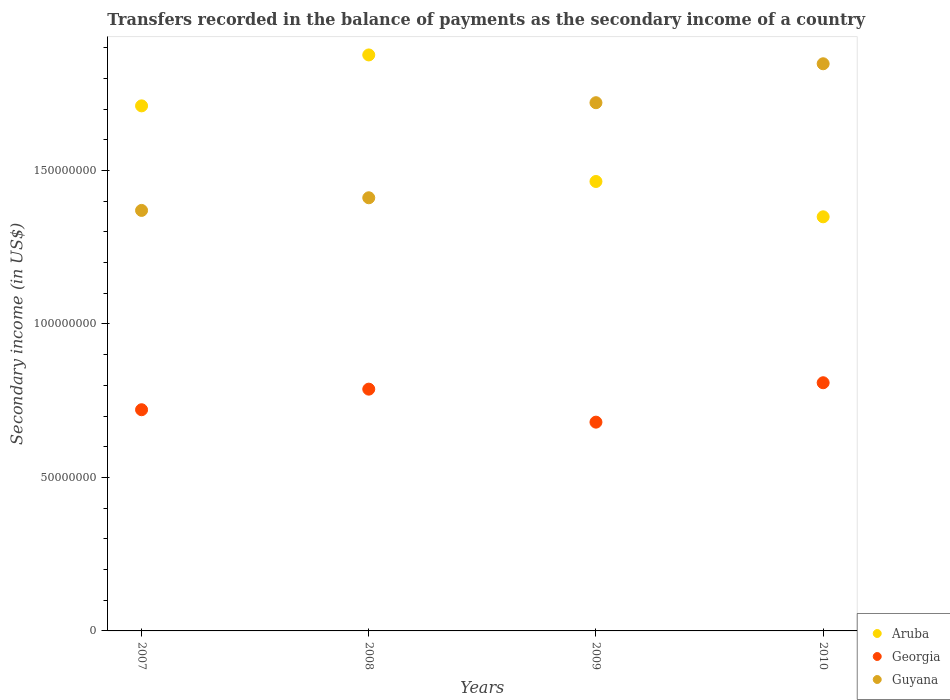How many different coloured dotlines are there?
Your answer should be compact. 3. Is the number of dotlines equal to the number of legend labels?
Your answer should be very brief. Yes. What is the secondary income of in Georgia in 2010?
Your answer should be very brief. 8.09e+07. Across all years, what is the maximum secondary income of in Georgia?
Give a very brief answer. 8.09e+07. Across all years, what is the minimum secondary income of in Aruba?
Your answer should be compact. 1.35e+08. In which year was the secondary income of in Aruba minimum?
Offer a terse response. 2010. What is the total secondary income of in Georgia in the graph?
Provide a short and direct response. 3.00e+08. What is the difference between the secondary income of in Guyana in 2008 and that in 2009?
Offer a very short reply. -3.10e+07. What is the difference between the secondary income of in Aruba in 2010 and the secondary income of in Guyana in 2009?
Ensure brevity in your answer.  -3.72e+07. What is the average secondary income of in Aruba per year?
Your response must be concise. 1.60e+08. In the year 2009, what is the difference between the secondary income of in Georgia and secondary income of in Guyana?
Provide a short and direct response. -1.04e+08. What is the ratio of the secondary income of in Aruba in 2007 to that in 2010?
Provide a succinct answer. 1.27. Is the secondary income of in Georgia in 2008 less than that in 2010?
Provide a succinct answer. Yes. What is the difference between the highest and the second highest secondary income of in Guyana?
Make the answer very short. 1.27e+07. What is the difference between the highest and the lowest secondary income of in Georgia?
Provide a short and direct response. 1.28e+07. Is it the case that in every year, the sum of the secondary income of in Guyana and secondary income of in Aruba  is greater than the secondary income of in Georgia?
Your answer should be very brief. Yes. Is the secondary income of in Aruba strictly greater than the secondary income of in Georgia over the years?
Your answer should be compact. Yes. How many dotlines are there?
Make the answer very short. 3. How many years are there in the graph?
Give a very brief answer. 4. Are the values on the major ticks of Y-axis written in scientific E-notation?
Offer a terse response. No. Does the graph contain any zero values?
Offer a very short reply. No. Does the graph contain grids?
Provide a short and direct response. No. Where does the legend appear in the graph?
Offer a terse response. Bottom right. How many legend labels are there?
Offer a terse response. 3. What is the title of the graph?
Provide a short and direct response. Transfers recorded in the balance of payments as the secondary income of a country. What is the label or title of the X-axis?
Give a very brief answer. Years. What is the label or title of the Y-axis?
Keep it short and to the point. Secondary income (in US$). What is the Secondary income (in US$) of Aruba in 2007?
Your response must be concise. 1.71e+08. What is the Secondary income (in US$) of Georgia in 2007?
Make the answer very short. 7.21e+07. What is the Secondary income (in US$) in Guyana in 2007?
Make the answer very short. 1.37e+08. What is the Secondary income (in US$) of Aruba in 2008?
Give a very brief answer. 1.88e+08. What is the Secondary income (in US$) of Georgia in 2008?
Your response must be concise. 7.88e+07. What is the Secondary income (in US$) in Guyana in 2008?
Your answer should be very brief. 1.41e+08. What is the Secondary income (in US$) of Aruba in 2009?
Offer a terse response. 1.46e+08. What is the Secondary income (in US$) in Georgia in 2009?
Your response must be concise. 6.80e+07. What is the Secondary income (in US$) in Guyana in 2009?
Provide a short and direct response. 1.72e+08. What is the Secondary income (in US$) of Aruba in 2010?
Ensure brevity in your answer.  1.35e+08. What is the Secondary income (in US$) of Georgia in 2010?
Keep it short and to the point. 8.09e+07. What is the Secondary income (in US$) in Guyana in 2010?
Offer a very short reply. 1.85e+08. Across all years, what is the maximum Secondary income (in US$) in Aruba?
Keep it short and to the point. 1.88e+08. Across all years, what is the maximum Secondary income (in US$) in Georgia?
Offer a terse response. 8.09e+07. Across all years, what is the maximum Secondary income (in US$) in Guyana?
Ensure brevity in your answer.  1.85e+08. Across all years, what is the minimum Secondary income (in US$) in Aruba?
Your answer should be compact. 1.35e+08. Across all years, what is the minimum Secondary income (in US$) of Georgia?
Your answer should be compact. 6.80e+07. Across all years, what is the minimum Secondary income (in US$) of Guyana?
Give a very brief answer. 1.37e+08. What is the total Secondary income (in US$) in Aruba in the graph?
Ensure brevity in your answer.  6.40e+08. What is the total Secondary income (in US$) of Georgia in the graph?
Provide a short and direct response. 3.00e+08. What is the total Secondary income (in US$) of Guyana in the graph?
Ensure brevity in your answer.  6.35e+08. What is the difference between the Secondary income (in US$) of Aruba in 2007 and that in 2008?
Your answer should be compact. -1.66e+07. What is the difference between the Secondary income (in US$) in Georgia in 2007 and that in 2008?
Your answer should be compact. -6.70e+06. What is the difference between the Secondary income (in US$) of Guyana in 2007 and that in 2008?
Give a very brief answer. -4.12e+06. What is the difference between the Secondary income (in US$) of Aruba in 2007 and that in 2009?
Keep it short and to the point. 2.46e+07. What is the difference between the Secondary income (in US$) of Georgia in 2007 and that in 2009?
Your response must be concise. 4.05e+06. What is the difference between the Secondary income (in US$) of Guyana in 2007 and that in 2009?
Offer a very short reply. -3.51e+07. What is the difference between the Secondary income (in US$) of Aruba in 2007 and that in 2010?
Provide a short and direct response. 3.61e+07. What is the difference between the Secondary income (in US$) in Georgia in 2007 and that in 2010?
Give a very brief answer. -8.79e+06. What is the difference between the Secondary income (in US$) in Guyana in 2007 and that in 2010?
Your answer should be compact. -4.78e+07. What is the difference between the Secondary income (in US$) of Aruba in 2008 and that in 2009?
Your answer should be very brief. 4.12e+07. What is the difference between the Secondary income (in US$) of Georgia in 2008 and that in 2009?
Provide a succinct answer. 1.08e+07. What is the difference between the Secondary income (in US$) in Guyana in 2008 and that in 2009?
Your response must be concise. -3.10e+07. What is the difference between the Secondary income (in US$) in Aruba in 2008 and that in 2010?
Your response must be concise. 5.27e+07. What is the difference between the Secondary income (in US$) of Georgia in 2008 and that in 2010?
Ensure brevity in your answer.  -2.09e+06. What is the difference between the Secondary income (in US$) of Guyana in 2008 and that in 2010?
Your answer should be compact. -4.37e+07. What is the difference between the Secondary income (in US$) of Aruba in 2009 and that in 2010?
Ensure brevity in your answer.  1.15e+07. What is the difference between the Secondary income (in US$) of Georgia in 2009 and that in 2010?
Give a very brief answer. -1.28e+07. What is the difference between the Secondary income (in US$) of Guyana in 2009 and that in 2010?
Offer a terse response. -1.27e+07. What is the difference between the Secondary income (in US$) in Aruba in 2007 and the Secondary income (in US$) in Georgia in 2008?
Your answer should be very brief. 9.23e+07. What is the difference between the Secondary income (in US$) in Aruba in 2007 and the Secondary income (in US$) in Guyana in 2008?
Your answer should be very brief. 2.99e+07. What is the difference between the Secondary income (in US$) in Georgia in 2007 and the Secondary income (in US$) in Guyana in 2008?
Your response must be concise. -6.91e+07. What is the difference between the Secondary income (in US$) of Aruba in 2007 and the Secondary income (in US$) of Georgia in 2009?
Keep it short and to the point. 1.03e+08. What is the difference between the Secondary income (in US$) of Aruba in 2007 and the Secondary income (in US$) of Guyana in 2009?
Give a very brief answer. -1.03e+06. What is the difference between the Secondary income (in US$) of Georgia in 2007 and the Secondary income (in US$) of Guyana in 2009?
Offer a very short reply. -1.00e+08. What is the difference between the Secondary income (in US$) in Aruba in 2007 and the Secondary income (in US$) in Georgia in 2010?
Make the answer very short. 9.02e+07. What is the difference between the Secondary income (in US$) of Aruba in 2007 and the Secondary income (in US$) of Guyana in 2010?
Provide a short and direct response. -1.37e+07. What is the difference between the Secondary income (in US$) of Georgia in 2007 and the Secondary income (in US$) of Guyana in 2010?
Your answer should be very brief. -1.13e+08. What is the difference between the Secondary income (in US$) of Aruba in 2008 and the Secondary income (in US$) of Georgia in 2009?
Offer a terse response. 1.20e+08. What is the difference between the Secondary income (in US$) of Aruba in 2008 and the Secondary income (in US$) of Guyana in 2009?
Keep it short and to the point. 1.56e+07. What is the difference between the Secondary income (in US$) in Georgia in 2008 and the Secondary income (in US$) in Guyana in 2009?
Your answer should be compact. -9.33e+07. What is the difference between the Secondary income (in US$) of Aruba in 2008 and the Secondary income (in US$) of Georgia in 2010?
Provide a short and direct response. 1.07e+08. What is the difference between the Secondary income (in US$) of Aruba in 2008 and the Secondary income (in US$) of Guyana in 2010?
Your answer should be compact. 2.88e+06. What is the difference between the Secondary income (in US$) of Georgia in 2008 and the Secondary income (in US$) of Guyana in 2010?
Give a very brief answer. -1.06e+08. What is the difference between the Secondary income (in US$) in Aruba in 2009 and the Secondary income (in US$) in Georgia in 2010?
Your answer should be very brief. 6.56e+07. What is the difference between the Secondary income (in US$) of Aruba in 2009 and the Secondary income (in US$) of Guyana in 2010?
Offer a terse response. -3.83e+07. What is the difference between the Secondary income (in US$) in Georgia in 2009 and the Secondary income (in US$) in Guyana in 2010?
Offer a very short reply. -1.17e+08. What is the average Secondary income (in US$) of Aruba per year?
Give a very brief answer. 1.60e+08. What is the average Secondary income (in US$) of Georgia per year?
Ensure brevity in your answer.  7.49e+07. What is the average Secondary income (in US$) in Guyana per year?
Your response must be concise. 1.59e+08. In the year 2007, what is the difference between the Secondary income (in US$) in Aruba and Secondary income (in US$) in Georgia?
Your answer should be compact. 9.90e+07. In the year 2007, what is the difference between the Secondary income (in US$) in Aruba and Secondary income (in US$) in Guyana?
Provide a short and direct response. 3.41e+07. In the year 2007, what is the difference between the Secondary income (in US$) in Georgia and Secondary income (in US$) in Guyana?
Ensure brevity in your answer.  -6.49e+07. In the year 2008, what is the difference between the Secondary income (in US$) of Aruba and Secondary income (in US$) of Georgia?
Keep it short and to the point. 1.09e+08. In the year 2008, what is the difference between the Secondary income (in US$) in Aruba and Secondary income (in US$) in Guyana?
Your answer should be compact. 4.65e+07. In the year 2008, what is the difference between the Secondary income (in US$) in Georgia and Secondary income (in US$) in Guyana?
Give a very brief answer. -6.24e+07. In the year 2009, what is the difference between the Secondary income (in US$) of Aruba and Secondary income (in US$) of Georgia?
Offer a terse response. 7.84e+07. In the year 2009, what is the difference between the Secondary income (in US$) in Aruba and Secondary income (in US$) in Guyana?
Your response must be concise. -2.57e+07. In the year 2009, what is the difference between the Secondary income (in US$) in Georgia and Secondary income (in US$) in Guyana?
Ensure brevity in your answer.  -1.04e+08. In the year 2010, what is the difference between the Secondary income (in US$) in Aruba and Secondary income (in US$) in Georgia?
Your answer should be compact. 5.41e+07. In the year 2010, what is the difference between the Secondary income (in US$) of Aruba and Secondary income (in US$) of Guyana?
Your answer should be very brief. -4.99e+07. In the year 2010, what is the difference between the Secondary income (in US$) in Georgia and Secondary income (in US$) in Guyana?
Offer a terse response. -1.04e+08. What is the ratio of the Secondary income (in US$) of Aruba in 2007 to that in 2008?
Offer a very short reply. 0.91. What is the ratio of the Secondary income (in US$) in Georgia in 2007 to that in 2008?
Offer a terse response. 0.91. What is the ratio of the Secondary income (in US$) of Guyana in 2007 to that in 2008?
Provide a short and direct response. 0.97. What is the ratio of the Secondary income (in US$) in Aruba in 2007 to that in 2009?
Offer a terse response. 1.17. What is the ratio of the Secondary income (in US$) of Georgia in 2007 to that in 2009?
Give a very brief answer. 1.06. What is the ratio of the Secondary income (in US$) in Guyana in 2007 to that in 2009?
Ensure brevity in your answer.  0.8. What is the ratio of the Secondary income (in US$) of Aruba in 2007 to that in 2010?
Give a very brief answer. 1.27. What is the ratio of the Secondary income (in US$) of Georgia in 2007 to that in 2010?
Make the answer very short. 0.89. What is the ratio of the Secondary income (in US$) of Guyana in 2007 to that in 2010?
Keep it short and to the point. 0.74. What is the ratio of the Secondary income (in US$) in Aruba in 2008 to that in 2009?
Provide a succinct answer. 1.28. What is the ratio of the Secondary income (in US$) in Georgia in 2008 to that in 2009?
Your answer should be very brief. 1.16. What is the ratio of the Secondary income (in US$) of Guyana in 2008 to that in 2009?
Provide a short and direct response. 0.82. What is the ratio of the Secondary income (in US$) of Aruba in 2008 to that in 2010?
Your answer should be very brief. 1.39. What is the ratio of the Secondary income (in US$) of Georgia in 2008 to that in 2010?
Provide a succinct answer. 0.97. What is the ratio of the Secondary income (in US$) of Guyana in 2008 to that in 2010?
Provide a short and direct response. 0.76. What is the ratio of the Secondary income (in US$) of Aruba in 2009 to that in 2010?
Give a very brief answer. 1.09. What is the ratio of the Secondary income (in US$) in Georgia in 2009 to that in 2010?
Make the answer very short. 0.84. What is the ratio of the Secondary income (in US$) of Guyana in 2009 to that in 2010?
Ensure brevity in your answer.  0.93. What is the difference between the highest and the second highest Secondary income (in US$) of Aruba?
Provide a short and direct response. 1.66e+07. What is the difference between the highest and the second highest Secondary income (in US$) of Georgia?
Make the answer very short. 2.09e+06. What is the difference between the highest and the second highest Secondary income (in US$) in Guyana?
Provide a succinct answer. 1.27e+07. What is the difference between the highest and the lowest Secondary income (in US$) of Aruba?
Keep it short and to the point. 5.27e+07. What is the difference between the highest and the lowest Secondary income (in US$) of Georgia?
Your answer should be very brief. 1.28e+07. What is the difference between the highest and the lowest Secondary income (in US$) in Guyana?
Provide a succinct answer. 4.78e+07. 